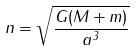Convert formula to latex. <formula><loc_0><loc_0><loc_500><loc_500>n = \sqrt { \frac { G ( M + m ) } { a ^ { 3 } } }</formula> 